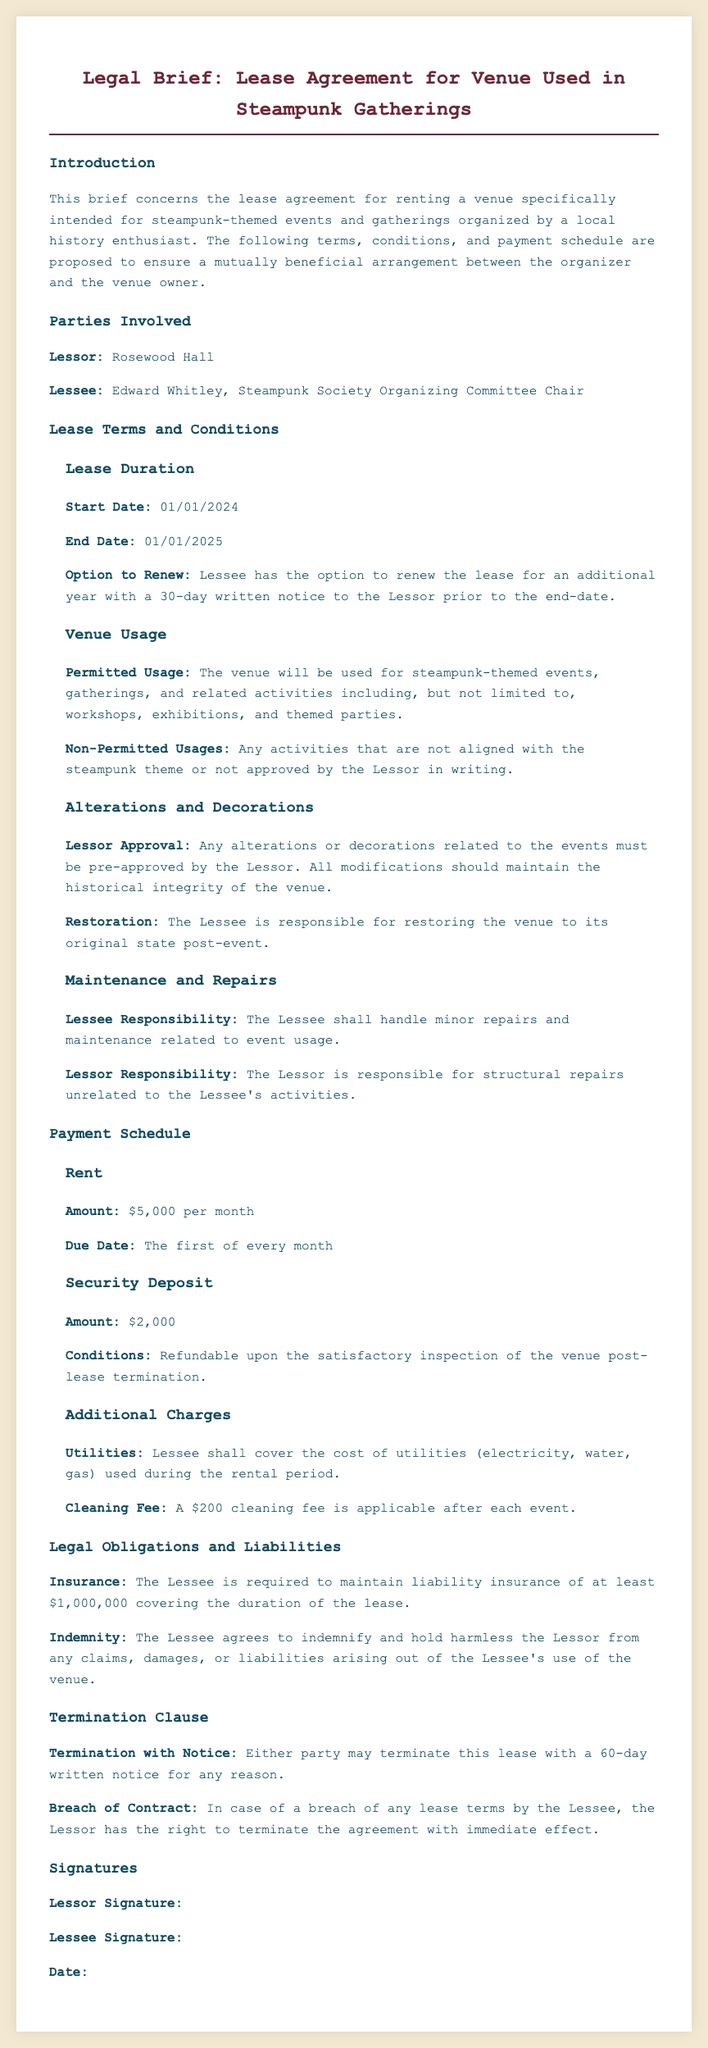What is the start date of the lease? The start date outlined in the document is found under the lease duration section.
Answer: 01/01/2024 Who is the lessee? The lessee is identified in the parties involved section of the document.
Answer: Edward Whitley What is the monthly rent amount? The monthly rent is specified in the payment schedule section as the amount due.
Answer: $5,000 What is the security deposit amount? The security deposit amount is mentioned in the payment schedule under additional charges.
Answer: $2,000 What is the notice period for termination? The termination clause specifies the notice period required for either party.
Answer: 60 days What types of events are permitted in the venue? The permitted usage is listed in the venue usage subsection of lease terms.
Answer: Steampunk-themed events How long is the lease duration? The lease duration is inferred from the start and end dates specified in the lease terms section.
Answer: One year What is the cleaning fee after each event? The cleaning fee is listed under additional charges in the payment schedule.
Answer: $200 What type of insurance does the lessee need to maintain? The legal obligations section specifies the type of insurance required.
Answer: Liability insurance What happens if there is a breach of contract? The consequences of a breach are stated in the termination clause.
Answer: Immediate termination 